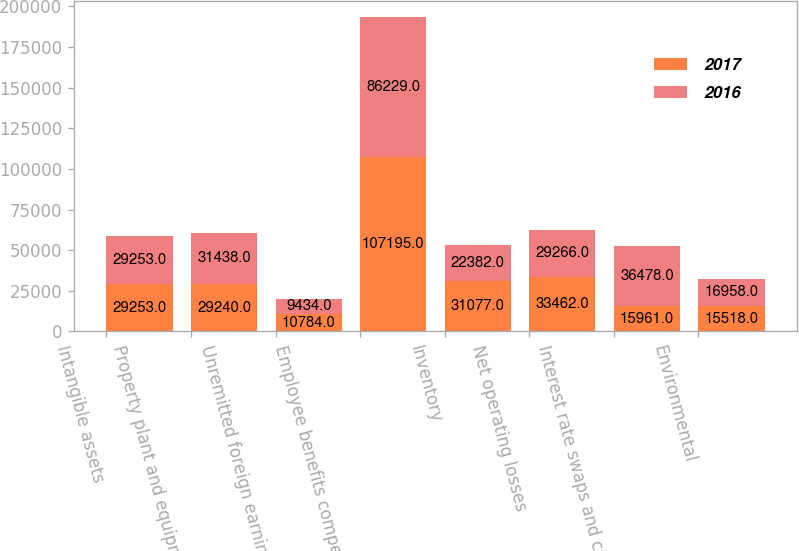Convert chart to OTSL. <chart><loc_0><loc_0><loc_500><loc_500><stacked_bar_chart><ecel><fcel>Intangible assets<fcel>Property plant and equipment<fcel>Unremitted foreign earnings<fcel>Employee benefits compensation<fcel>Inventory<fcel>Net operating losses<fcel>Interest rate swaps and caps<fcel>Environmental<nl><fcel>2017<fcel>29253<fcel>29240<fcel>10784<fcel>107195<fcel>31077<fcel>33462<fcel>15961<fcel>15518<nl><fcel>2016<fcel>29253<fcel>31438<fcel>9434<fcel>86229<fcel>22382<fcel>29266<fcel>36478<fcel>16958<nl></chart> 